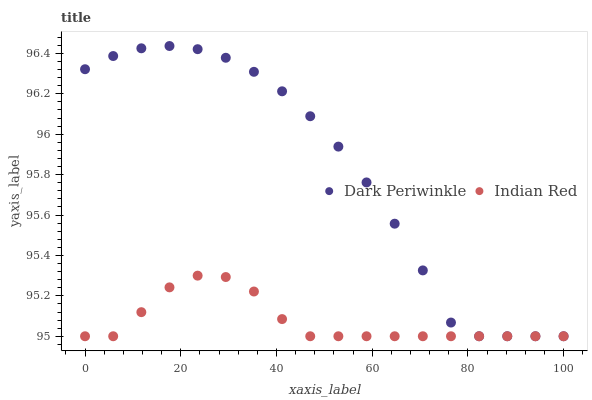Does Indian Red have the minimum area under the curve?
Answer yes or no. Yes. Does Dark Periwinkle have the maximum area under the curve?
Answer yes or no. Yes. Does Indian Red have the maximum area under the curve?
Answer yes or no. No. Is Indian Red the smoothest?
Answer yes or no. Yes. Is Dark Periwinkle the roughest?
Answer yes or no. Yes. Is Indian Red the roughest?
Answer yes or no. No. Does Dark Periwinkle have the lowest value?
Answer yes or no. Yes. Does Dark Periwinkle have the highest value?
Answer yes or no. Yes. Does Indian Red have the highest value?
Answer yes or no. No. Does Indian Red intersect Dark Periwinkle?
Answer yes or no. Yes. Is Indian Red less than Dark Periwinkle?
Answer yes or no. No. Is Indian Red greater than Dark Periwinkle?
Answer yes or no. No. 